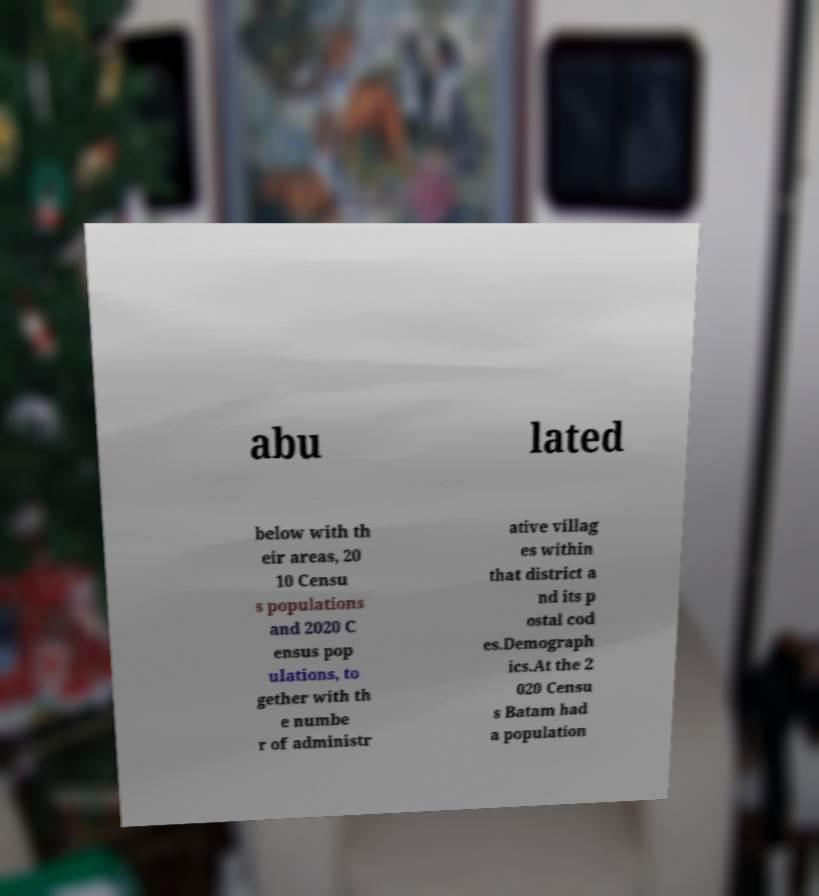Can you accurately transcribe the text from the provided image for me? abu lated below with th eir areas, 20 10 Censu s populations and 2020 C ensus pop ulations, to gether with th e numbe r of administr ative villag es within that district a nd its p ostal cod es.Demograph ics.At the 2 020 Censu s Batam had a population 